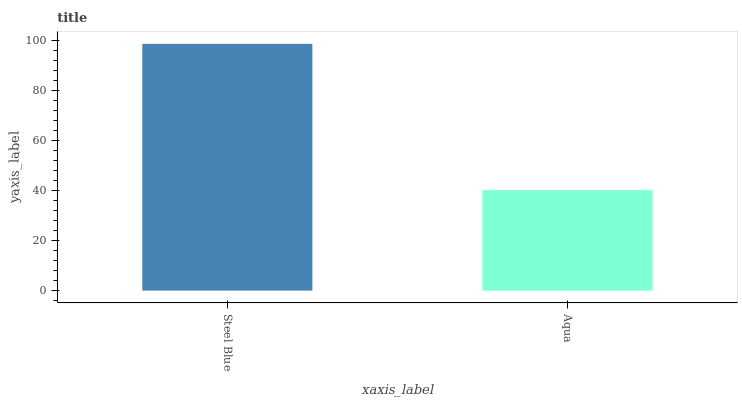Is Aqua the maximum?
Answer yes or no. No. Is Steel Blue greater than Aqua?
Answer yes or no. Yes. Is Aqua less than Steel Blue?
Answer yes or no. Yes. Is Aqua greater than Steel Blue?
Answer yes or no. No. Is Steel Blue less than Aqua?
Answer yes or no. No. Is Steel Blue the high median?
Answer yes or no. Yes. Is Aqua the low median?
Answer yes or no. Yes. Is Aqua the high median?
Answer yes or no. No. Is Steel Blue the low median?
Answer yes or no. No. 